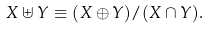Convert formula to latex. <formula><loc_0><loc_0><loc_500><loc_500>X \uplus Y \equiv ( X \oplus Y ) / ( X \cap Y ) .</formula> 